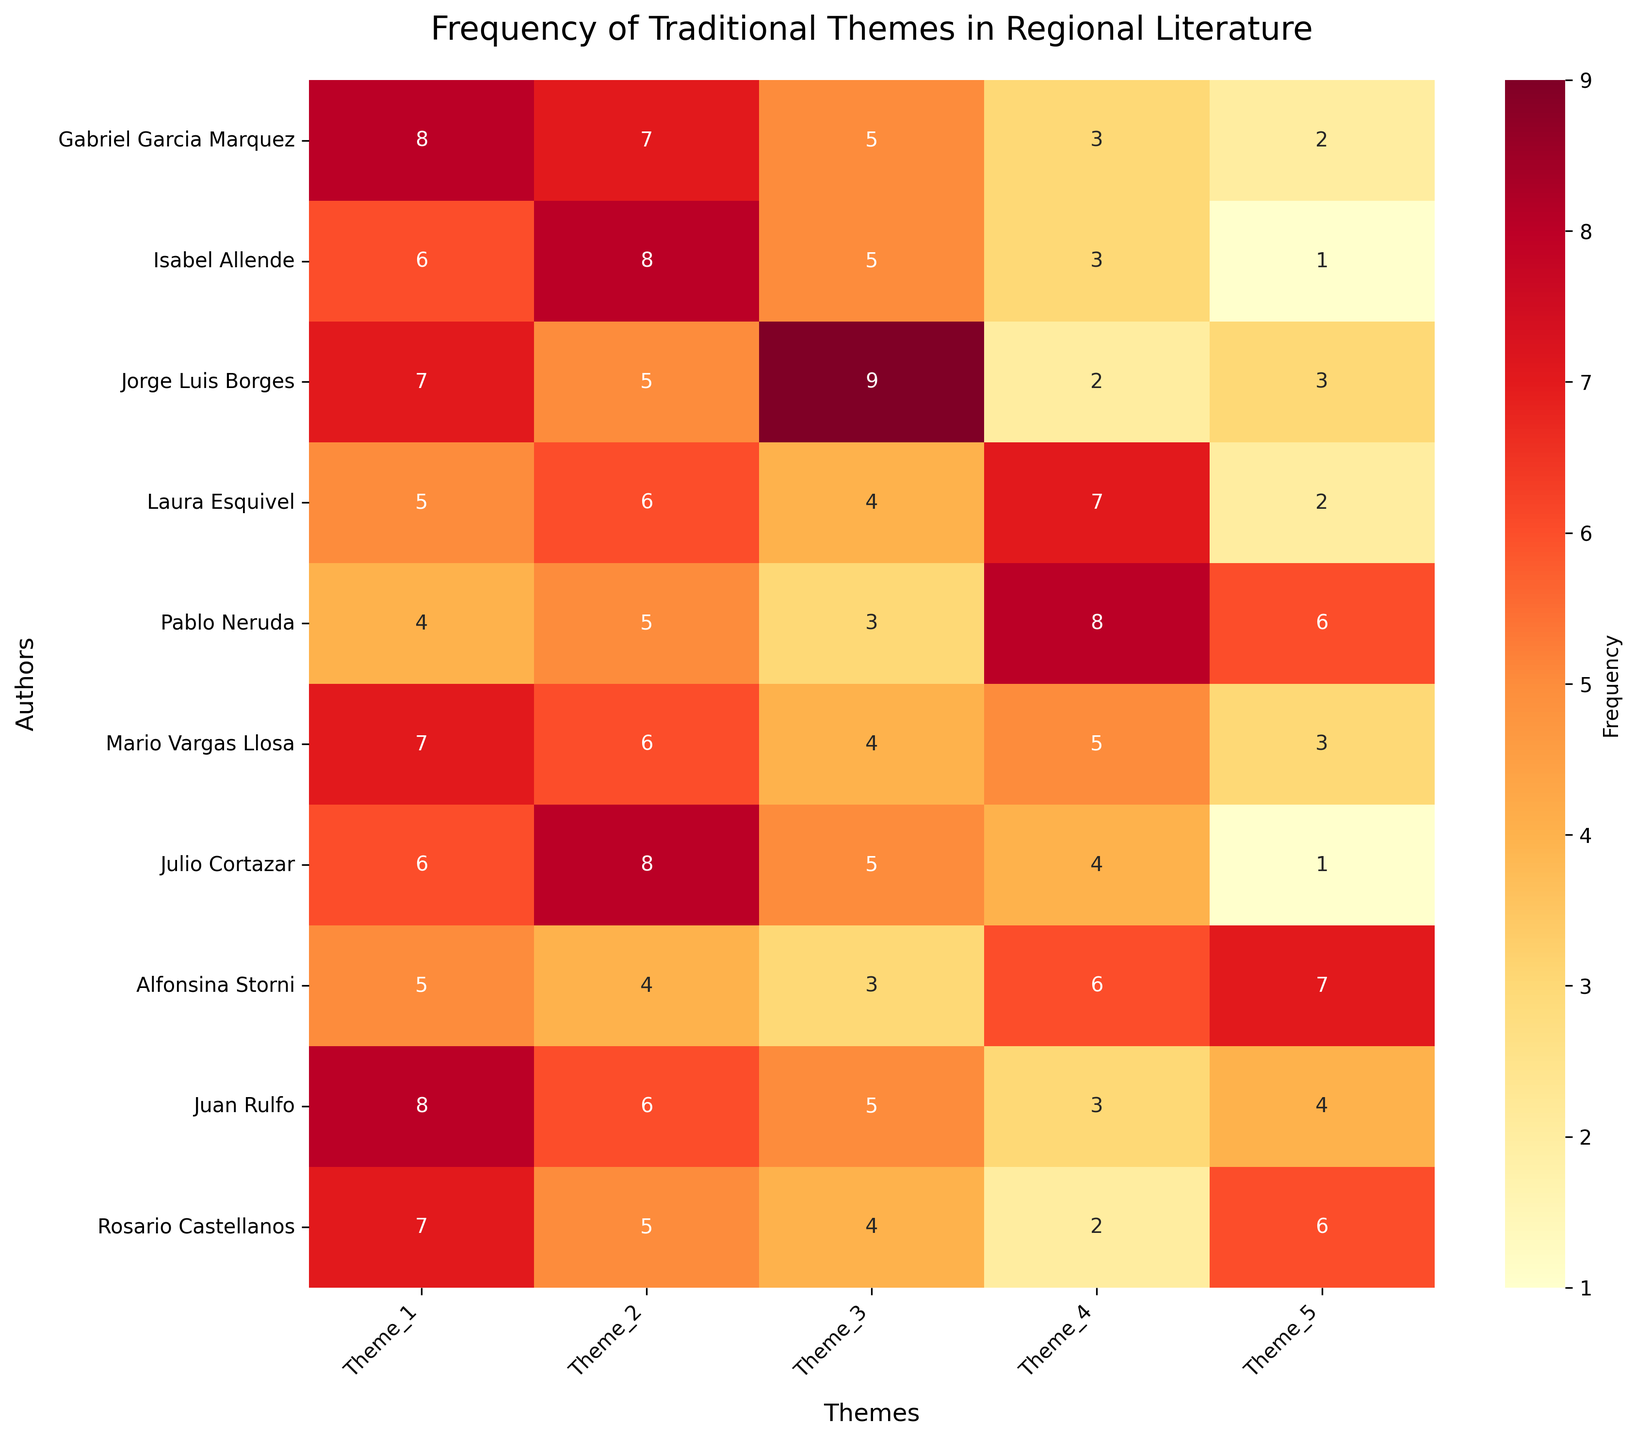What is the frequency of Theme 1 for Gabriel Garcia Marquez? To find this, look at the cell corresponding to Gabriel Garcia Marquez and Theme 1. The number displayed in this cell represents the frequency of Theme 1 for this author.
Answer: 8 How many authors have a frequency of 5 for Theme 3? Locate Theme 3 and count how many cells have a value of 5 in this column.
Answer: 3 Which author has the highest frequency for Theme 5? Compare all the values in the Theme 5 column and find the highest one. Check the corresponding author for this value.
Answer: Alfonsina Storni Between Isabel Allende and Jorge Luis Borges, who has a higher frequency for Theme 4? Compare the values for Theme 4 for both authors. Isabel Allende has 3, and Jorge Luis Borges has 2.
Answer: Isabel Allende What is the average frequency of Theme 2? Sum all the values in Theme 2 and divide by the number of authors (10). (7 + 8 + 5 + 6 + 5 + 6 + 8 + 4 + 6 + 5)/10 = 60/10 = 6
Answer: 6 Which author has the lowest total frequency across all themes? Calculate the sum of all theme values for each author, then identify the author with the lowest sum.
Answer: Pablo Neruda What is the difference in frequency of Theme 4 between Mario Vargas Llosa and Laura Esquivel? Find the values for Theme 4 for both authors and subtract the smaller value from the larger one. Mario Vargas Llosa has 5, and Laura Esquivel has 7. 7 - 5 = 2
Answer: 2 Which theme has the highest average frequency across all authors? Calculate the average frequency for each theme and compare them. (Theme 3: (5+5+9+4+3+4+5+3+5+4)/10 = 47/10 ≈ 4.7, Theme 4: (3+3+2+7+8+5+4+6+3+2)/10 = 43/10 = 4.3, so on)
Answer: Theme 1 How many themes does Julio Cortazar mention with a frequency of 8? Look at the row for Julio Cortazar and count how many cells have a value of 8.
Answer: 1 For which theme does Alfonsina Storni have the highest frequency, and what is the value? Find the theme with the highest number in the row corresponding to Alfonsina Storni. Theme 5 has the highest value of 7.
Answer: Theme 5, 7 